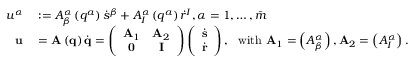Convert formula to latex. <formula><loc_0><loc_0><loc_500><loc_500>\begin{array} { r l } { u ^ { \alpha } } & \colon = A _ { \beta } ^ { \alpha } \left ( q ^ { a } \right ) \dot { s } ^ { \beta } + A _ { I } ^ { \alpha } \left ( q ^ { a } \right ) \dot { r } ^ { I } , \alpha = 1 , \dots , \bar { m } } \\ { u } & = A \left ( q \right ) \dot { q } = \left ( \begin{array} { c c } { A _ { 1 } } & { A _ { 2 } } \\ { 0 } & { I } \end{array} \right ) \left ( \begin{array} { c } { \dot { s } } \\ { \dot { r } } \end{array} \right ) , \ \ w i t h \ A _ { 1 } = \left ( A _ { \beta } ^ { \alpha } \right ) , A _ { 2 } = \left ( A _ { I } ^ { \alpha } \right ) . } \end{array}</formula> 